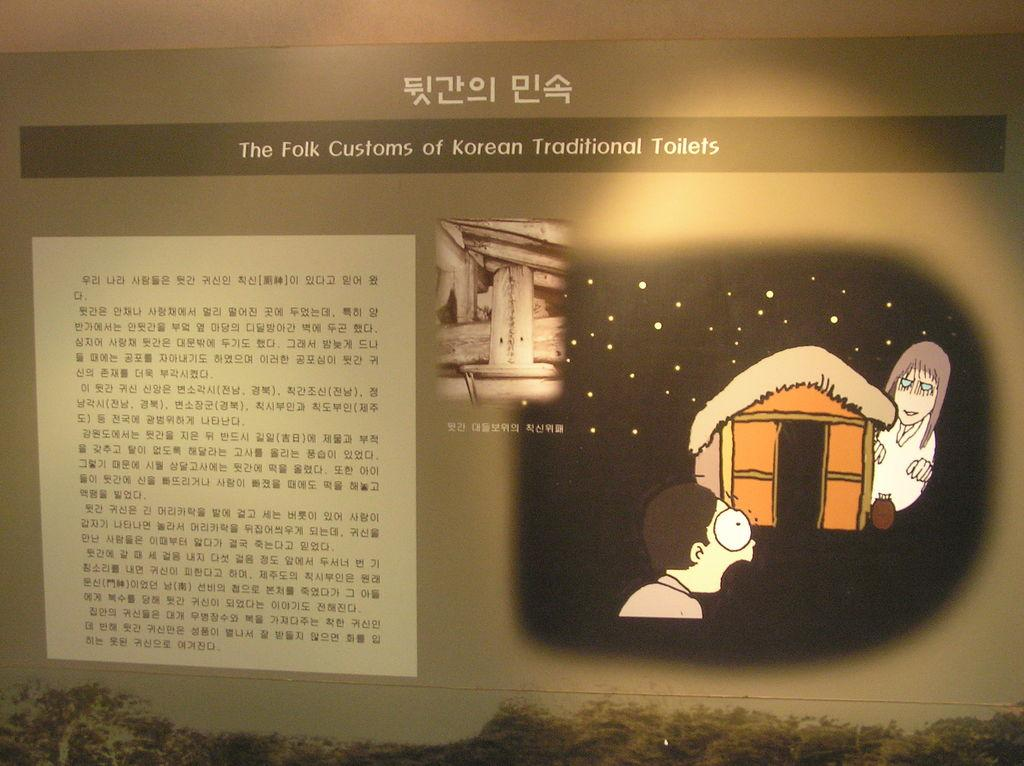<image>
Share a concise interpretation of the image provided. A sign on a wall labeled the folk customs of Korean traditional toilets 